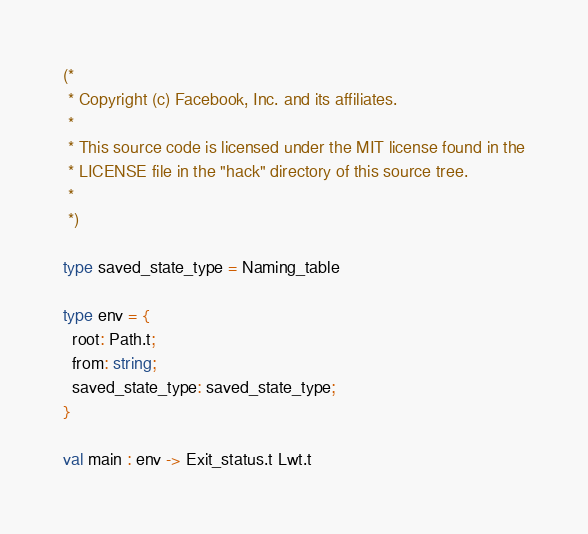Convert code to text. <code><loc_0><loc_0><loc_500><loc_500><_OCaml_>(*
 * Copyright (c) Facebook, Inc. and its affiliates.
 *
 * This source code is licensed under the MIT license found in the
 * LICENSE file in the "hack" directory of this source tree.
 *
 *)

type saved_state_type = Naming_table

type env = {
  root: Path.t;
  from: string;
  saved_state_type: saved_state_type;
}

val main : env -> Exit_status.t Lwt.t
</code> 